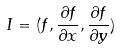<formula> <loc_0><loc_0><loc_500><loc_500>I = ( f , \frac { \partial f } { \partial x } , \frac { \partial f } { \partial y } )</formula> 